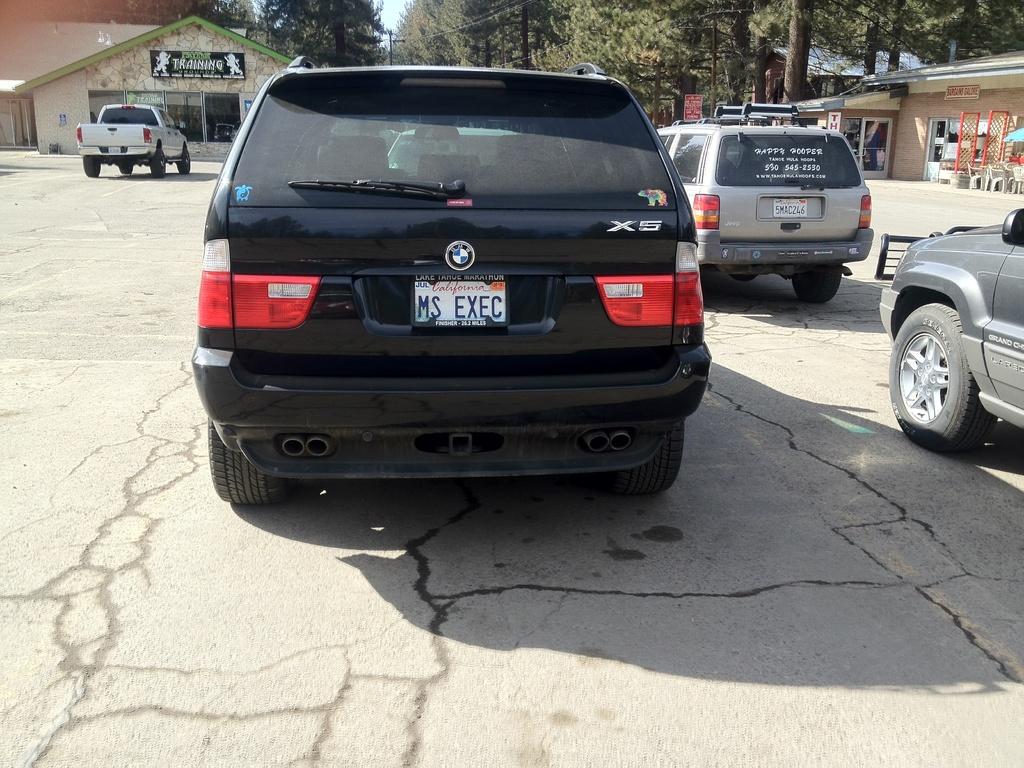What state is the black suv from?
Ensure brevity in your answer.  California. What is the model of the bmw?
Provide a succinct answer. X5. 